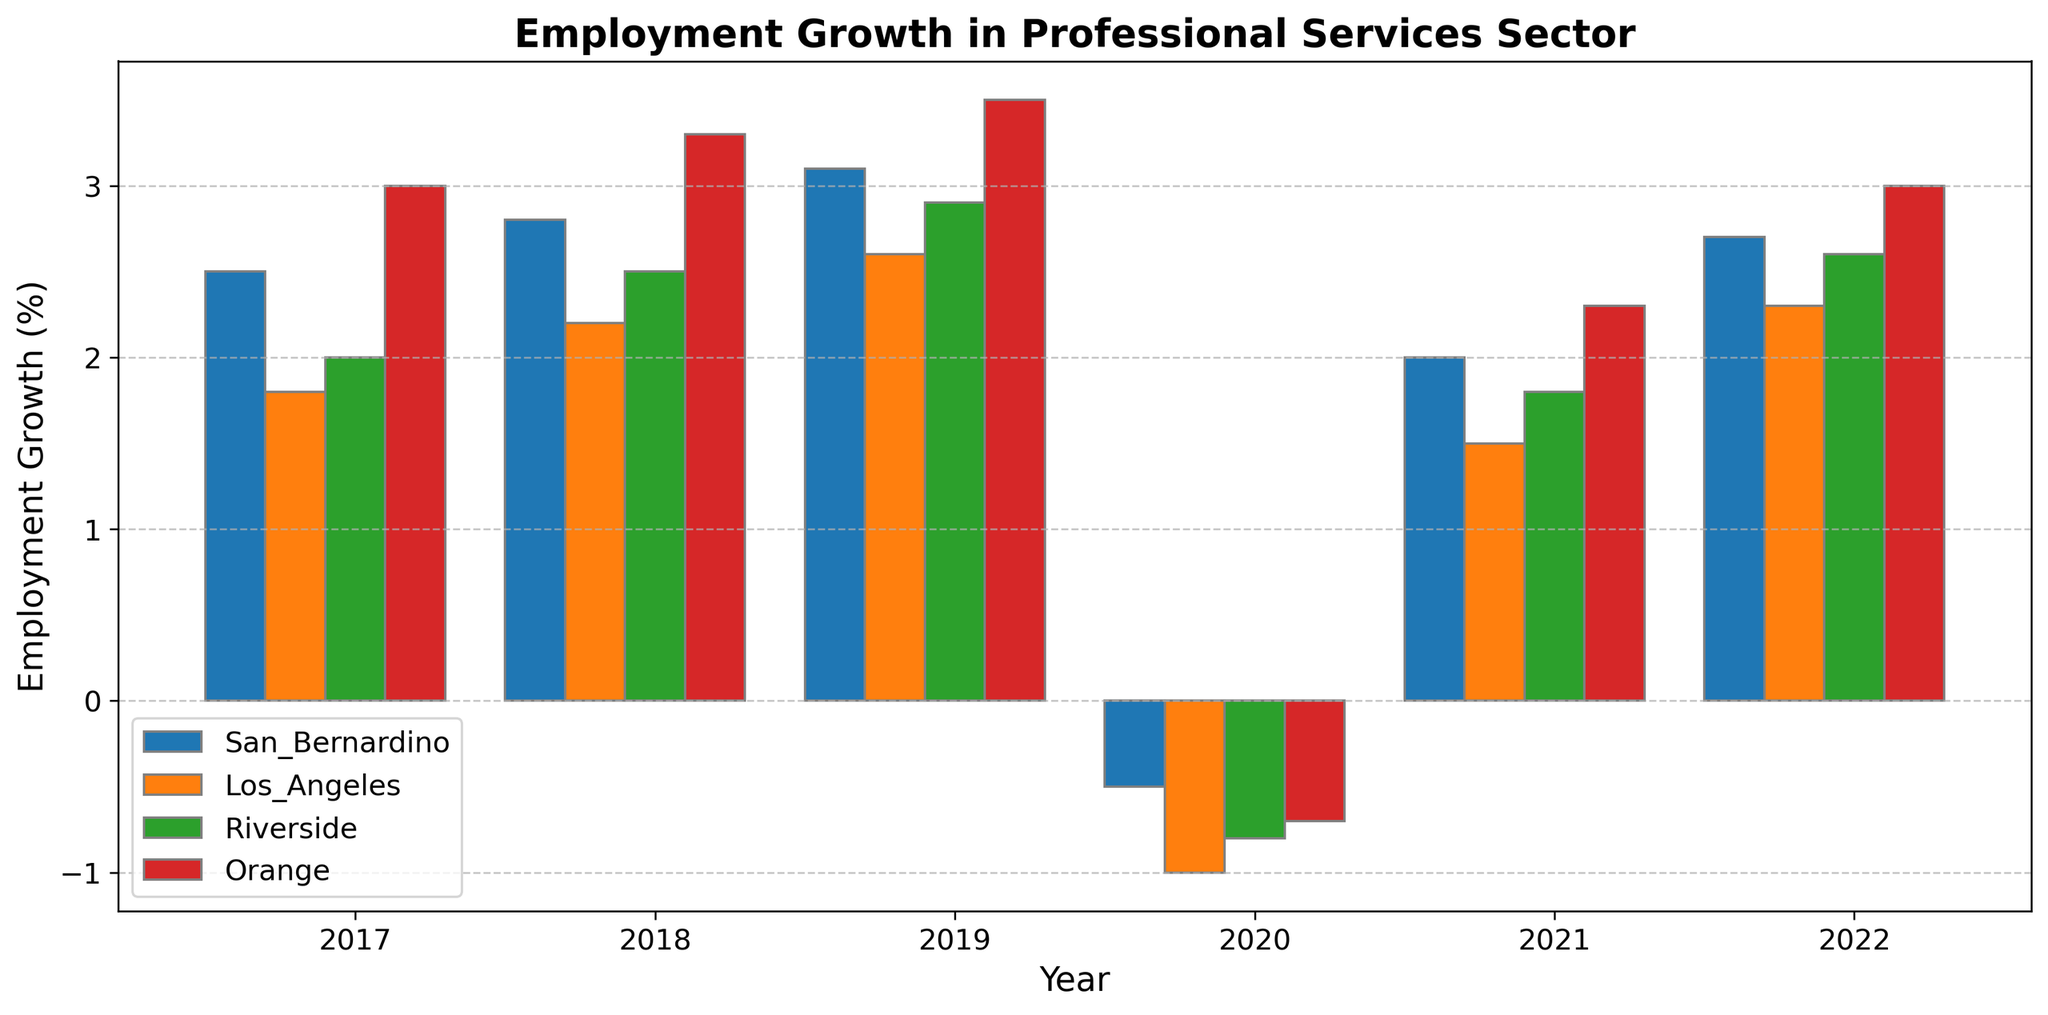What was the employment growth in the professional services sector for San Bernardino in 2020? Look at the specific bar for San Bernardino in 2020 on the x-axis. The height of the bar for 2020 is slightly below the 0 line, indicating that employment growth was negative. The exact value is -0.5%.
Answer: -0.5% Which county had the highest employment growth in 2019? Identify the bar with the greatest height for the year 2019. The tallest bar is for Orange County, indicating the highest employment growth of 3.5%.
Answer: Orange County How did San Bernardino's employment growth in 2022 compare to Los Angeles' in the same year? Compare the height of the bars for San Bernardino and Los Angeles in 2022. San Bernardino's bar is taller, showing higher growth (2.7%) compared to Los Angeles (2.3%).
Answer: San Bernardino was higher In which year did Riverside experience negative employment growth, and what was the growth rate? Identify the year when Riverside's bar goes below the 0 line. The specific year is 2020, with a growth rate of -0.8%.
Answer: 2020, -0.8% What is the average employment growth in the professional services sector for Orange County from 2017 to 2022? Calculate the average by adding the employment growth values for Orange County over the years (3.0 + 3.3 + 3.5 - 0.7 + 2.3 + 3.0) and dividing by the number of years (6). The sum is 14.4, and the average is 14.4 / 6 = 2.4%.
Answer: 2.4% Between San Bernardino and Riverside, which county saw a more significant decline in employment growth during 2020, and by how much? Identify the employment growth for both counties in 2020 (San Bernardino: -0.5%, Riverside: -0.8%). Calculate the difference in their declines: -0.5 - (-0.8) = 0.3%.
Answer: Riverside by 0.3% How does the employment growth pattern in San Bernardino from 2017 to 2022 compare to that in Los Angeles for the same period? Compare year-by-year the height of the bars for San Bernardino and Los Angeles. San Bernardino generally shows a higher growth rate than Los Angeles in all years except 2020, where both counties experience negative growth, and 2021 where Los Angeles has lower growth.
Answer: San Bernardino generally higher What was the cumulative employment growth for Riverside from 2017 to 2022? Sum the employment growth percentages for Riverside over the given years (2.0 + 2.5 + 2.9 - 0.8 + 1.8 + 2.6). The cumulative growth is 11.0%.
Answer: 11.0% In which year did Orange County have the lowest employment growth, and what was the value? Identify the year with the lowest bar for Orange County, which is 2020 with an employment growth of -0.7%.
Answer: 2020, -0.7% What is the difference in employment growth between San Bernardino and Riverside in 2019? Identify the employment growth for San Bernardino and Riverside in 2019 (San Bernardino: 3.1%, Riverside: 2.9%). Calculate the difference: 3.1 - 2.9 = 0.2%.
Answer: 0.2% 